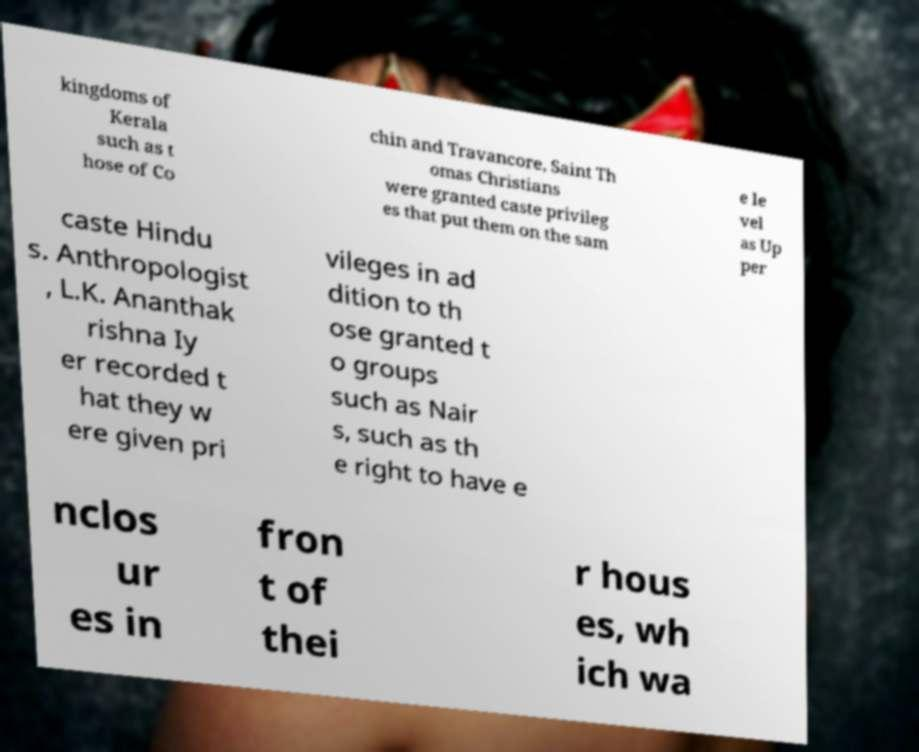Please read and relay the text visible in this image. What does it say? kingdoms of Kerala such as t hose of Co chin and Travancore, Saint Th omas Christians were granted caste privileg es that put them on the sam e le vel as Up per caste Hindu s. Anthropologist , L.K. Ananthak rishna Iy er recorded t hat they w ere given pri vileges in ad dition to th ose granted t o groups such as Nair s, such as th e right to have e nclos ur es in fron t of thei r hous es, wh ich wa 